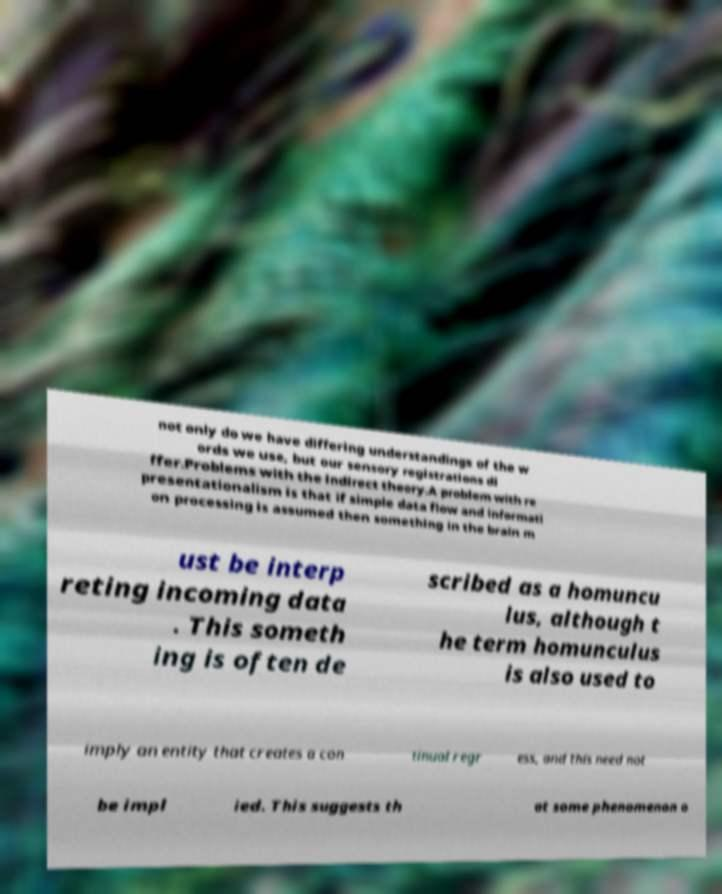For documentation purposes, I need the text within this image transcribed. Could you provide that? not only do we have differing understandings of the w ords we use, but our sensory registrations di ffer.Problems with the indirect theory.A problem with re presentationalism is that if simple data flow and informati on processing is assumed then something in the brain m ust be interp reting incoming data . This someth ing is often de scribed as a homuncu lus, although t he term homunculus is also used to imply an entity that creates a con tinual regr ess, and this need not be impl ied. This suggests th at some phenomenon o 